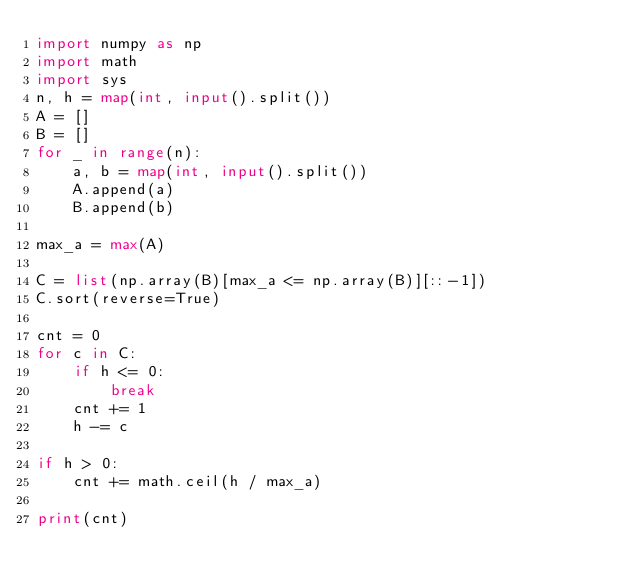Convert code to text. <code><loc_0><loc_0><loc_500><loc_500><_Python_>import numpy as np
import math
import sys
n, h = map(int, input().split())
A = []
B = []
for _ in range(n):
    a, b = map(int, input().split())
    A.append(a)
    B.append(b)

max_a = max(A)
  
C = list(np.array(B)[max_a <= np.array(B)][::-1])
C.sort(reverse=True)

cnt = 0
for c in C:
    if h <= 0:
        break
    cnt += 1
    h -= c

if h > 0:
    cnt += math.ceil(h / max_a)

print(cnt)</code> 